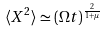<formula> <loc_0><loc_0><loc_500><loc_500>\langle X ^ { 2 } \rangle \simeq ( \Omega t ) ^ { \frac { 2 } { 1 + \mu } }</formula> 